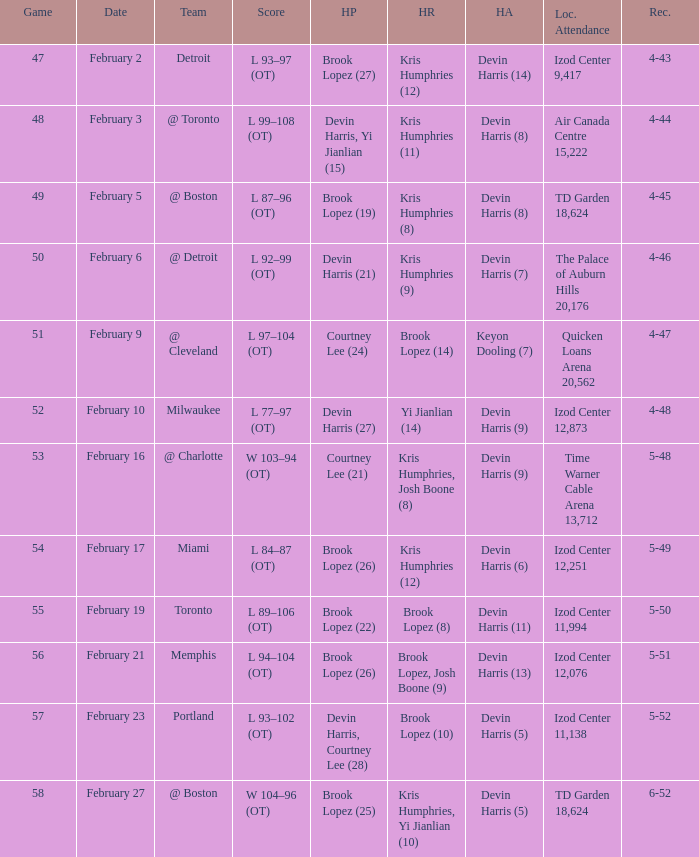What was the score of the game in which Brook Lopez (8) did the high rebounds? L 89–106 (OT). 